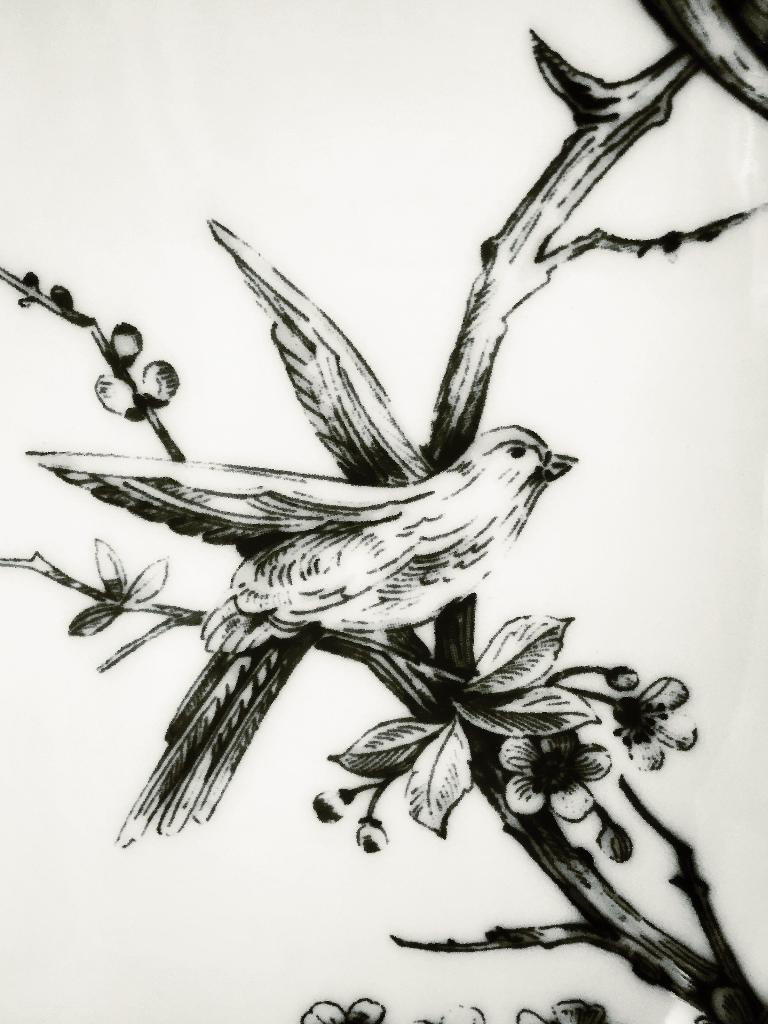Please provide a concise description of this image. In this image, we can see depiction of a bird on tree. 